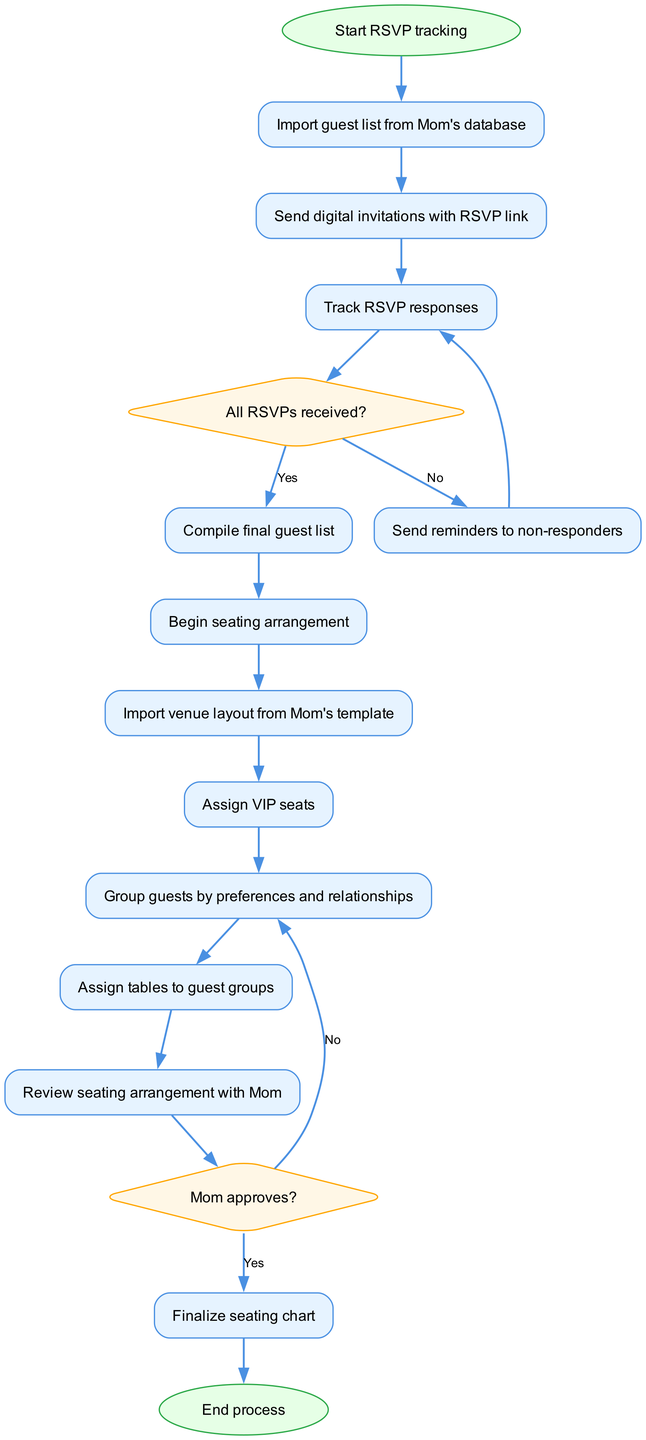What is the first step in the diagram? The first step is represented by the node "start" which indicates the beginning of the RSVP tracking process. Thus, the flow begins with this action.
Answer: Start RSVP tracking How many decision points are there in the diagram? The diagram contains three decision points, as indicated by the nodes labeled "decision_rsvp" and "decision_approve." These nodes represent choices that affect the flow of the process.
Answer: 3 What action follows after sending invitations? After sending invitations, the next action is to "track RSVP responses," as indicated by the connection from the "send_invitations" node to the "track_responses" node.
Answer: Track RSVP responses What happens if not all RSVPs are received? If not all RSVPs are received, the process sends reminders to non-responders, as specified by the connection from the "decision_rsvp" node (with the label "No") to the "send_reminders" node.
Answer: Send reminders to non-responders What is the final step before the process ends? The final step before the process ends is "finalize seating chart," which is the last action taken before reaching the "end" node in the workflow.
Answer: Finalize seating chart What needs to be reviewed before finalizing the seating? Before finalizing the seating, the arrangement must be reviewed with Mom, represented by the node "review_arrangement." This step is crucial in ensuring approval before finalizing the seating chart.
Answer: Review seating arrangement with Mom How are guests grouped in the seating arrangement process? Guests are grouped by preferences and relationships, as indicated by the node "group_guests." This action organizes guests to create suitable groupings for the seating arrangement.
Answer: Group guests by preferences and relationships What is required after compiling the final guest list? After compiling the final guest list, the next action is to "start seating" which begins the process of arranging the guests at the gala dinner.
Answer: Begin seating arrangement 